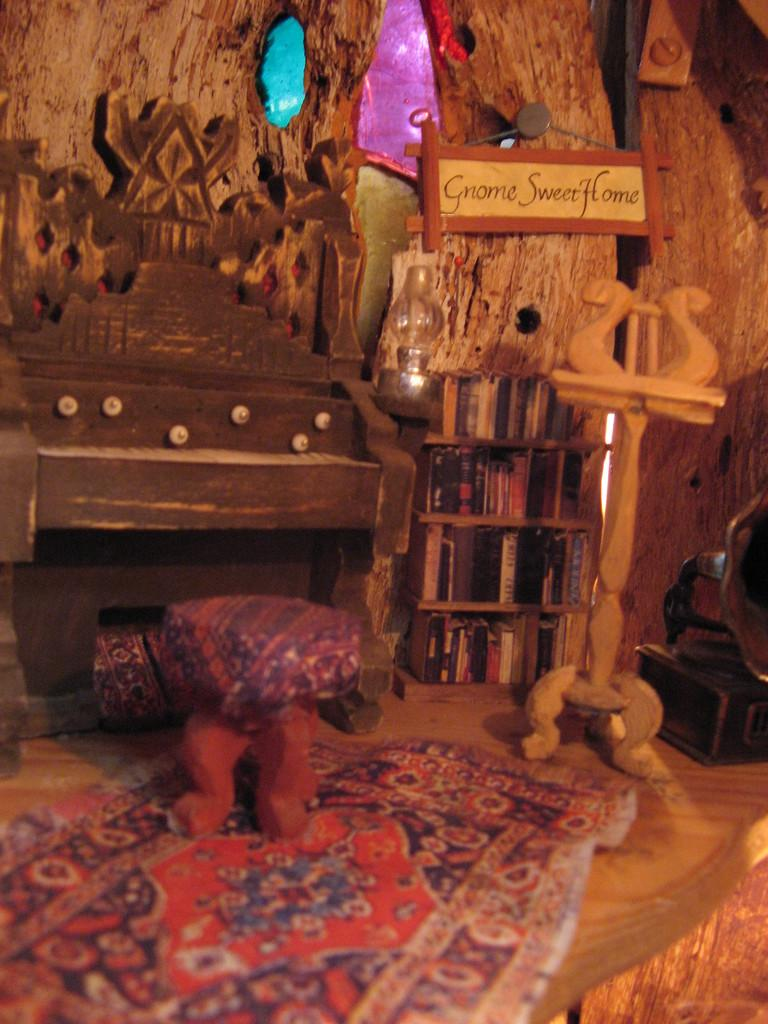What type of material is used for the objects in the image? The objects in the image are made of wood. What type of furniture is present in the image? There is a stool and a stand in the image. What can be found in the racks in the image? There are books in the racks in the image. What is written on the board in the image? There is a board with text in the image. What type of device is present in the image? There is a gramophone in the image. How many people are working in the cellar in the image? There is no cellar or people working in the image; it features wooden objects, a stool, a stand, books in racks, a board with text, and a gramophone. 